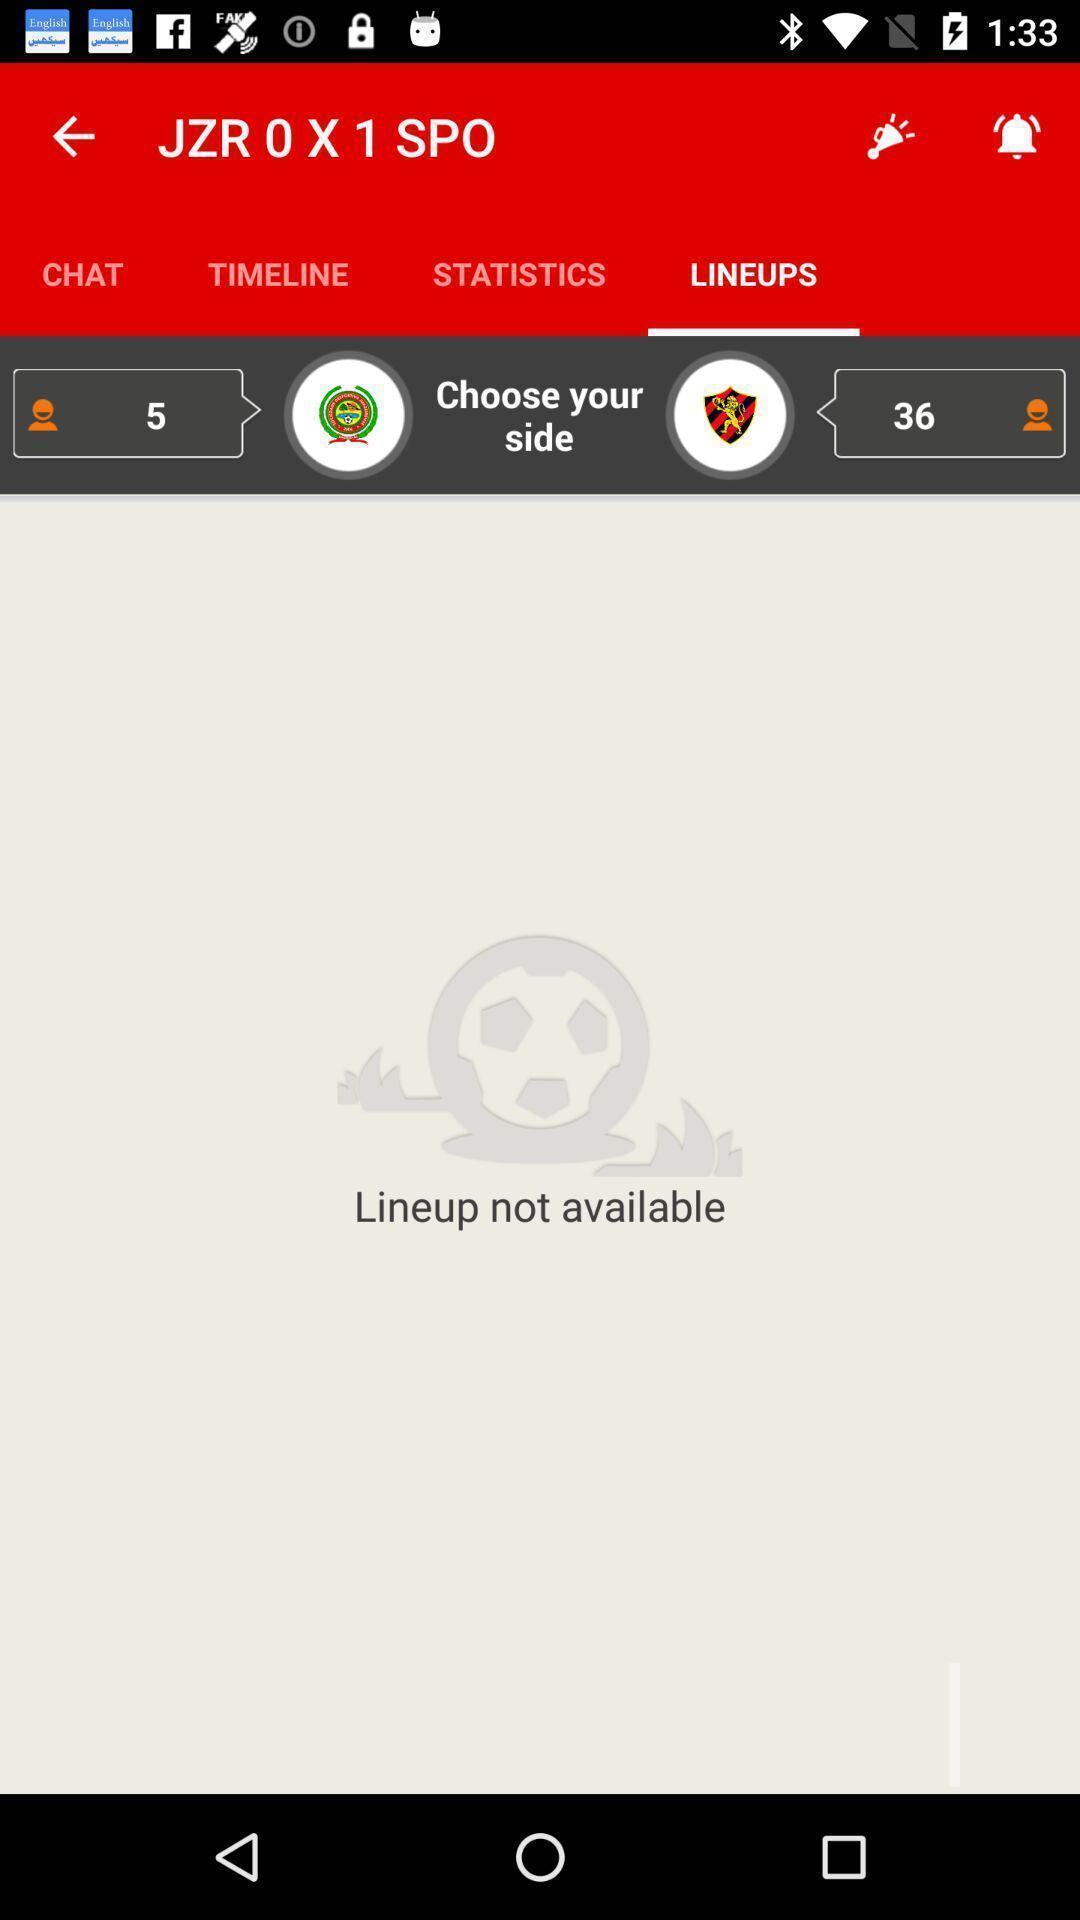Summarize the main components in this picture. Screen showing lineups page. 